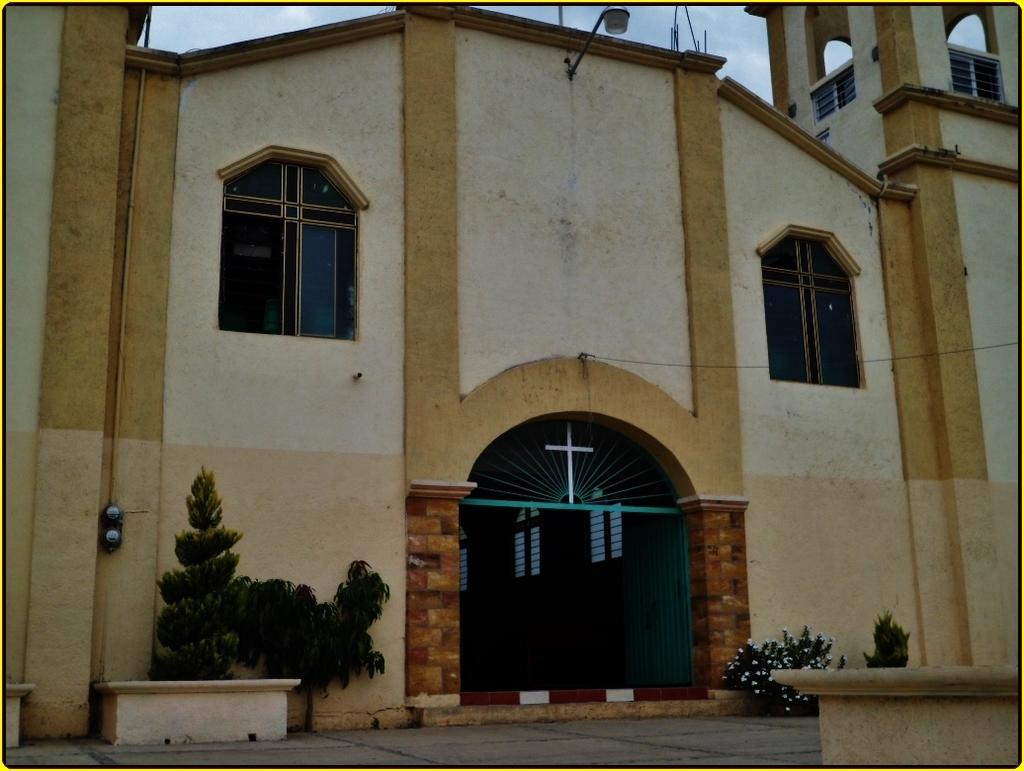What type of building is shown in the image? The image depicts a church. What can be seen in front of the church? There are plants and flowers in front of the church. What feature is present at the top of the church? There is a light at the top of the church. How would you describe the sky in the image? The sky is cloudy in the image. How many worms can be seen crawling on the church in the image? There are no worms present in the image; it features a church with plants and flowers in front of it. What type of adjustment is being made by the girls in the image? There are no girls present in the image; it features a church with plants and flowers in front of it. 